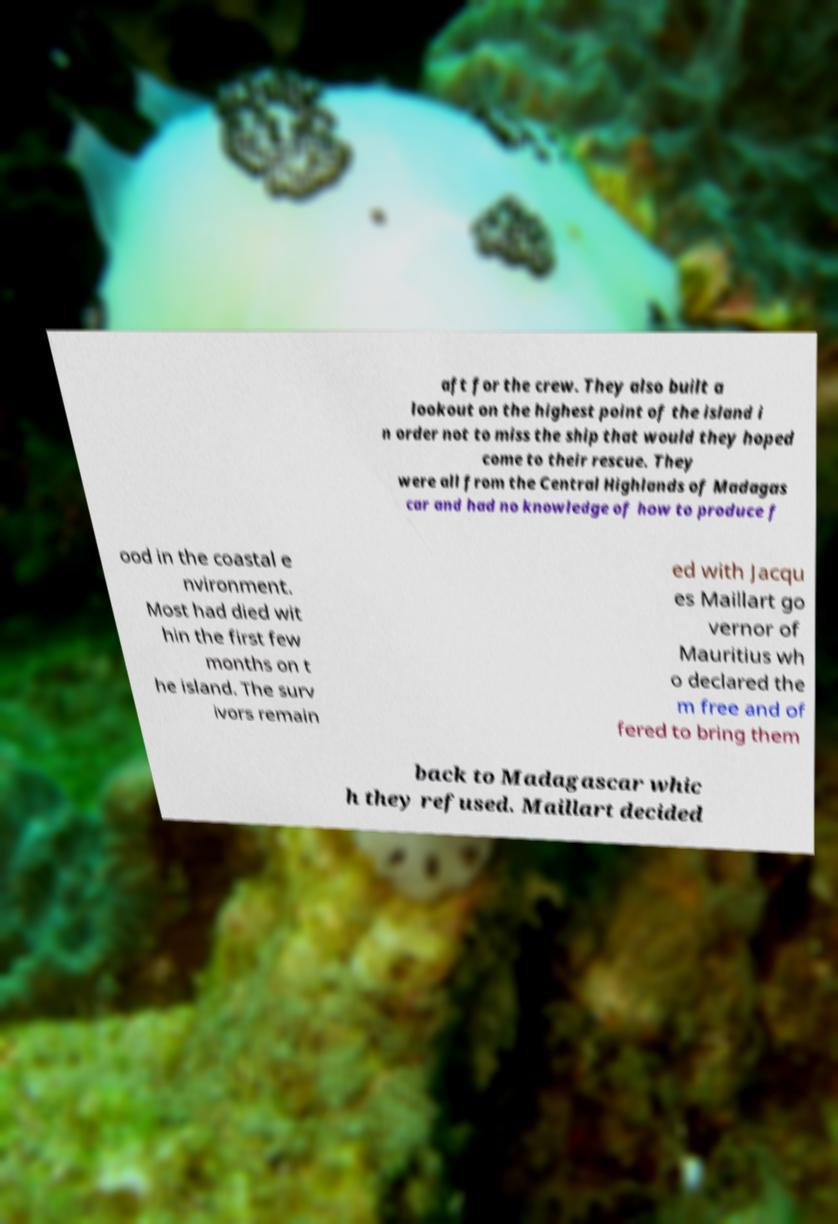What messages or text are displayed in this image? I need them in a readable, typed format. aft for the crew. They also built a lookout on the highest point of the island i n order not to miss the ship that would they hoped come to their rescue. They were all from the Central Highlands of Madagas car and had no knowledge of how to produce f ood in the coastal e nvironment. Most had died wit hin the first few months on t he island. The surv ivors remain ed with Jacqu es Maillart go vernor of Mauritius wh o declared the m free and of fered to bring them back to Madagascar whic h they refused. Maillart decided 